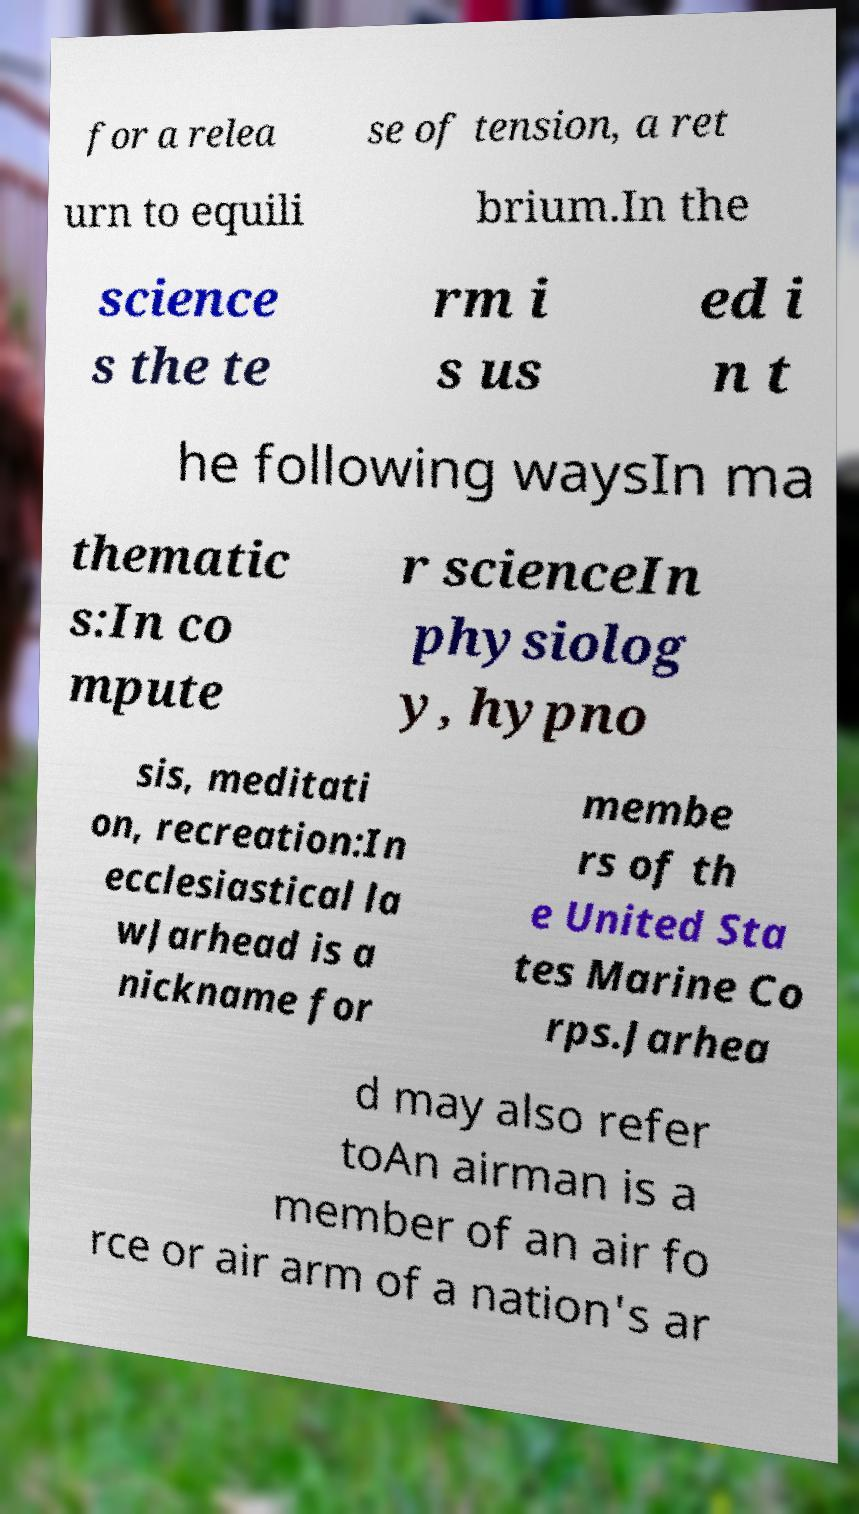Please identify and transcribe the text found in this image. for a relea se of tension, a ret urn to equili brium.In the science s the te rm i s us ed i n t he following waysIn ma thematic s:In co mpute r scienceIn physiolog y, hypno sis, meditati on, recreation:In ecclesiastical la wJarhead is a nickname for membe rs of th e United Sta tes Marine Co rps.Jarhea d may also refer toAn airman is a member of an air fo rce or air arm of a nation's ar 